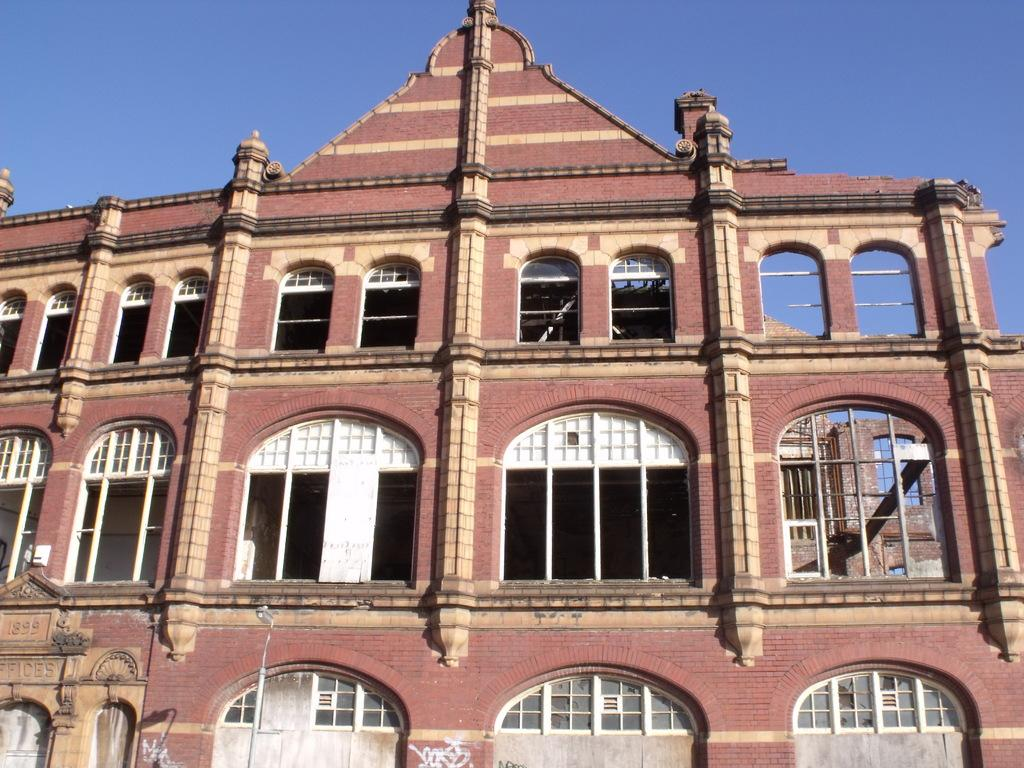What is located in the bottom left corner of the image? There is a pole in the bottom left corner of the image. What structure is in the middle of the image? There is a building in the middle of the image. What is visible at the top of the image? The sky is visible at the top of the image. What type of health advice is advertised on the pole in the image? There is no advertisement or health advice present on the pole in the image. What design elements can be seen in the building in the image? The provided facts do not mention any specific design elements of the building in the image. 